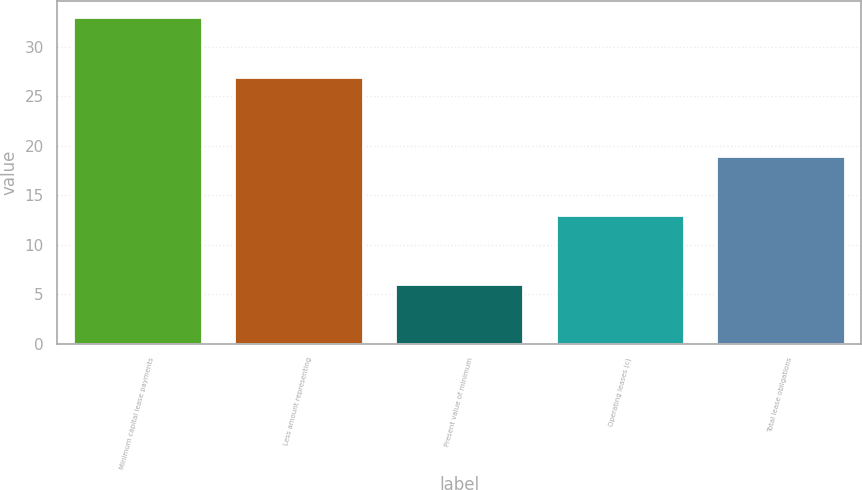Convert chart. <chart><loc_0><loc_0><loc_500><loc_500><bar_chart><fcel>Minimum capital lease payments<fcel>Less amount representing<fcel>Present value of minimum<fcel>Operating leases (c)<fcel>Total lease obligations<nl><fcel>33<fcel>27<fcel>6<fcel>13<fcel>19<nl></chart> 